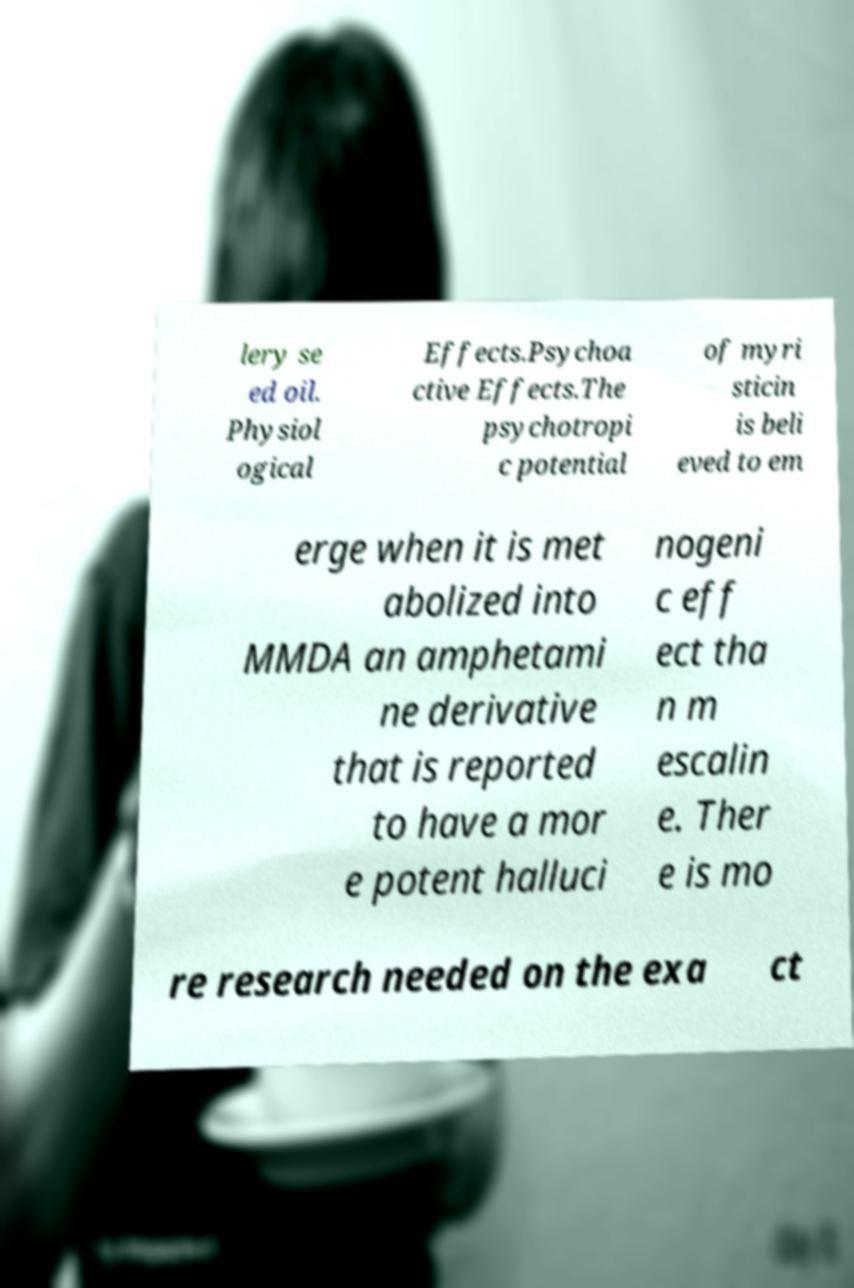Could you extract and type out the text from this image? lery se ed oil. Physiol ogical Effects.Psychoa ctive Effects.The psychotropi c potential of myri sticin is beli eved to em erge when it is met abolized into MMDA an amphetami ne derivative that is reported to have a mor e potent halluci nogeni c eff ect tha n m escalin e. Ther e is mo re research needed on the exa ct 